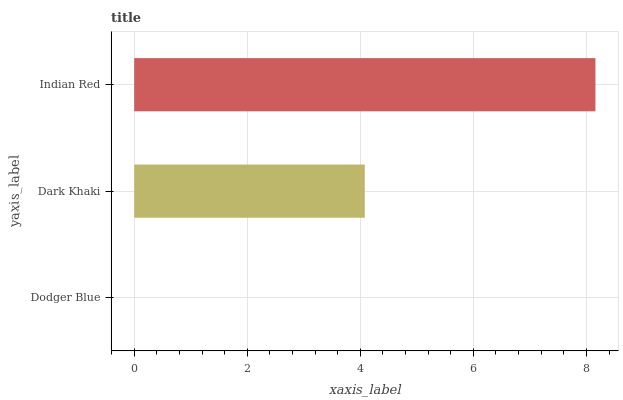Is Dodger Blue the minimum?
Answer yes or no. Yes. Is Indian Red the maximum?
Answer yes or no. Yes. Is Dark Khaki the minimum?
Answer yes or no. No. Is Dark Khaki the maximum?
Answer yes or no. No. Is Dark Khaki greater than Dodger Blue?
Answer yes or no. Yes. Is Dodger Blue less than Dark Khaki?
Answer yes or no. Yes. Is Dodger Blue greater than Dark Khaki?
Answer yes or no. No. Is Dark Khaki less than Dodger Blue?
Answer yes or no. No. Is Dark Khaki the high median?
Answer yes or no. Yes. Is Dark Khaki the low median?
Answer yes or no. Yes. Is Indian Red the high median?
Answer yes or no. No. Is Indian Red the low median?
Answer yes or no. No. 